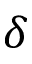<formula> <loc_0><loc_0><loc_500><loc_500>\delta</formula> 